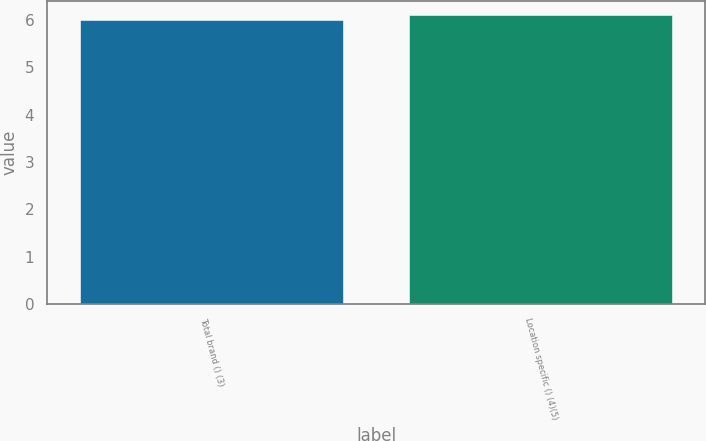<chart> <loc_0><loc_0><loc_500><loc_500><bar_chart><fcel>Total brand () (3)<fcel>Location specific () (4)(5)<nl><fcel>6<fcel>6.1<nl></chart> 